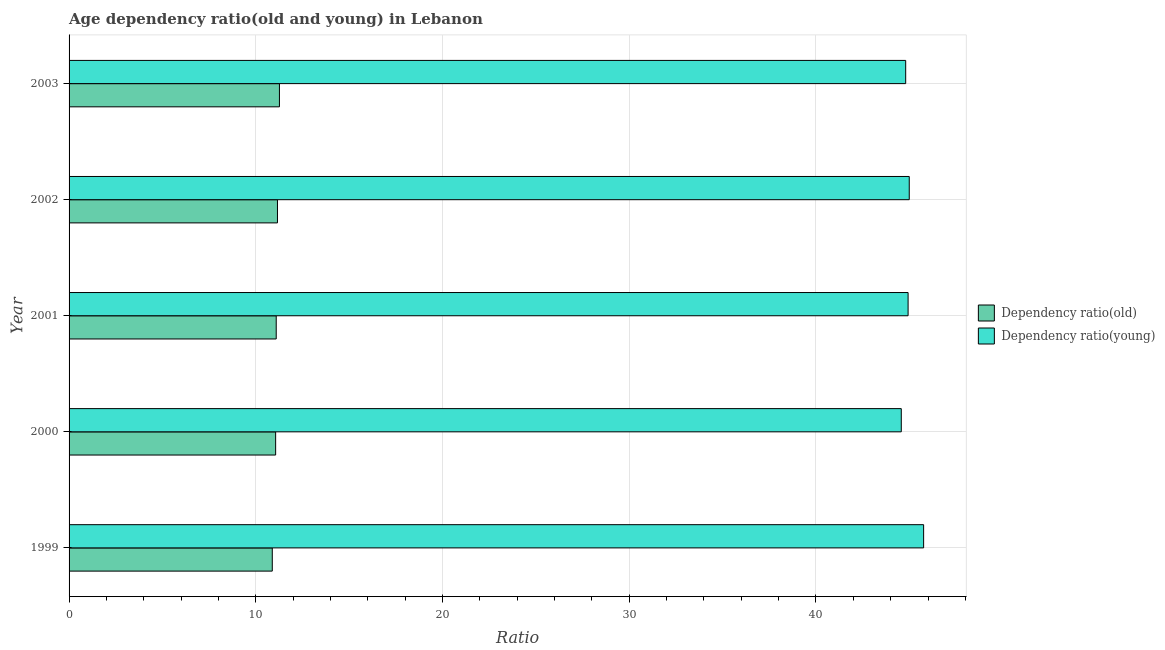How many groups of bars are there?
Give a very brief answer. 5. Are the number of bars on each tick of the Y-axis equal?
Keep it short and to the point. Yes. How many bars are there on the 3rd tick from the bottom?
Your answer should be very brief. 2. What is the age dependency ratio(old) in 2003?
Your response must be concise. 11.27. Across all years, what is the maximum age dependency ratio(young)?
Provide a short and direct response. 45.77. Across all years, what is the minimum age dependency ratio(old)?
Give a very brief answer. 10.88. In which year was the age dependency ratio(old) maximum?
Give a very brief answer. 2003. What is the total age dependency ratio(old) in the graph?
Your answer should be compact. 55.47. What is the difference between the age dependency ratio(old) in 2001 and that in 2003?
Your answer should be compact. -0.17. What is the difference between the age dependency ratio(young) in 1999 and the age dependency ratio(old) in 2000?
Keep it short and to the point. 34.7. What is the average age dependency ratio(young) per year?
Keep it short and to the point. 45.01. In the year 2000, what is the difference between the age dependency ratio(old) and age dependency ratio(young)?
Keep it short and to the point. -33.51. What is the ratio of the age dependency ratio(young) in 2002 to that in 2003?
Give a very brief answer. 1. Is the difference between the age dependency ratio(young) in 1999 and 2000 greater than the difference between the age dependency ratio(old) in 1999 and 2000?
Ensure brevity in your answer.  Yes. What is the difference between the highest and the second highest age dependency ratio(young)?
Make the answer very short. 0.77. What is the difference between the highest and the lowest age dependency ratio(old)?
Your response must be concise. 0.38. What does the 2nd bar from the top in 1999 represents?
Your answer should be very brief. Dependency ratio(old). What does the 2nd bar from the bottom in 1999 represents?
Offer a terse response. Dependency ratio(young). How many bars are there?
Provide a short and direct response. 10. Does the graph contain any zero values?
Provide a succinct answer. No. Where does the legend appear in the graph?
Provide a short and direct response. Center right. How are the legend labels stacked?
Your answer should be compact. Vertical. What is the title of the graph?
Make the answer very short. Age dependency ratio(old and young) in Lebanon. Does "Malaria" appear as one of the legend labels in the graph?
Your answer should be very brief. No. What is the label or title of the X-axis?
Your answer should be compact. Ratio. What is the label or title of the Y-axis?
Provide a succinct answer. Year. What is the Ratio of Dependency ratio(old) in 1999?
Your response must be concise. 10.88. What is the Ratio of Dependency ratio(young) in 1999?
Ensure brevity in your answer.  45.77. What is the Ratio in Dependency ratio(old) in 2000?
Offer a very short reply. 11.06. What is the Ratio in Dependency ratio(young) in 2000?
Your answer should be very brief. 44.57. What is the Ratio of Dependency ratio(old) in 2001?
Your answer should be compact. 11.09. What is the Ratio in Dependency ratio(young) in 2001?
Offer a terse response. 44.93. What is the Ratio in Dependency ratio(old) in 2002?
Make the answer very short. 11.16. What is the Ratio of Dependency ratio(young) in 2002?
Your answer should be compact. 45. What is the Ratio of Dependency ratio(old) in 2003?
Give a very brief answer. 11.27. What is the Ratio of Dependency ratio(young) in 2003?
Your response must be concise. 44.81. Across all years, what is the maximum Ratio in Dependency ratio(old)?
Your response must be concise. 11.27. Across all years, what is the maximum Ratio in Dependency ratio(young)?
Keep it short and to the point. 45.77. Across all years, what is the minimum Ratio of Dependency ratio(old)?
Offer a terse response. 10.88. Across all years, what is the minimum Ratio of Dependency ratio(young)?
Ensure brevity in your answer.  44.57. What is the total Ratio of Dependency ratio(old) in the graph?
Your response must be concise. 55.47. What is the total Ratio of Dependency ratio(young) in the graph?
Make the answer very short. 225.07. What is the difference between the Ratio of Dependency ratio(old) in 1999 and that in 2000?
Offer a terse response. -0.18. What is the difference between the Ratio in Dependency ratio(young) in 1999 and that in 2000?
Provide a succinct answer. 1.2. What is the difference between the Ratio in Dependency ratio(old) in 1999 and that in 2001?
Provide a succinct answer. -0.21. What is the difference between the Ratio of Dependency ratio(young) in 1999 and that in 2001?
Give a very brief answer. 0.83. What is the difference between the Ratio of Dependency ratio(old) in 1999 and that in 2002?
Keep it short and to the point. -0.28. What is the difference between the Ratio in Dependency ratio(young) in 1999 and that in 2002?
Make the answer very short. 0.77. What is the difference between the Ratio of Dependency ratio(old) in 1999 and that in 2003?
Your response must be concise. -0.38. What is the difference between the Ratio of Dependency ratio(young) in 1999 and that in 2003?
Keep it short and to the point. 0.96. What is the difference between the Ratio of Dependency ratio(old) in 2000 and that in 2001?
Make the answer very short. -0.03. What is the difference between the Ratio in Dependency ratio(young) in 2000 and that in 2001?
Make the answer very short. -0.36. What is the difference between the Ratio of Dependency ratio(old) in 2000 and that in 2002?
Make the answer very short. -0.1. What is the difference between the Ratio of Dependency ratio(young) in 2000 and that in 2002?
Your response must be concise. -0.43. What is the difference between the Ratio of Dependency ratio(old) in 2000 and that in 2003?
Offer a very short reply. -0.2. What is the difference between the Ratio of Dependency ratio(young) in 2000 and that in 2003?
Ensure brevity in your answer.  -0.24. What is the difference between the Ratio of Dependency ratio(old) in 2001 and that in 2002?
Your response must be concise. -0.07. What is the difference between the Ratio of Dependency ratio(young) in 2001 and that in 2002?
Give a very brief answer. -0.06. What is the difference between the Ratio of Dependency ratio(old) in 2001 and that in 2003?
Your response must be concise. -0.17. What is the difference between the Ratio in Dependency ratio(young) in 2001 and that in 2003?
Make the answer very short. 0.13. What is the difference between the Ratio of Dependency ratio(old) in 2002 and that in 2003?
Your response must be concise. -0.11. What is the difference between the Ratio of Dependency ratio(young) in 2002 and that in 2003?
Offer a very short reply. 0.19. What is the difference between the Ratio of Dependency ratio(old) in 1999 and the Ratio of Dependency ratio(young) in 2000?
Offer a very short reply. -33.69. What is the difference between the Ratio in Dependency ratio(old) in 1999 and the Ratio in Dependency ratio(young) in 2001?
Offer a very short reply. -34.05. What is the difference between the Ratio of Dependency ratio(old) in 1999 and the Ratio of Dependency ratio(young) in 2002?
Ensure brevity in your answer.  -34.11. What is the difference between the Ratio in Dependency ratio(old) in 1999 and the Ratio in Dependency ratio(young) in 2003?
Your response must be concise. -33.92. What is the difference between the Ratio of Dependency ratio(old) in 2000 and the Ratio of Dependency ratio(young) in 2001?
Your response must be concise. -33.87. What is the difference between the Ratio of Dependency ratio(old) in 2000 and the Ratio of Dependency ratio(young) in 2002?
Offer a very short reply. -33.93. What is the difference between the Ratio of Dependency ratio(old) in 2000 and the Ratio of Dependency ratio(young) in 2003?
Provide a short and direct response. -33.74. What is the difference between the Ratio in Dependency ratio(old) in 2001 and the Ratio in Dependency ratio(young) in 2002?
Provide a succinct answer. -33.9. What is the difference between the Ratio in Dependency ratio(old) in 2001 and the Ratio in Dependency ratio(young) in 2003?
Offer a terse response. -33.71. What is the difference between the Ratio in Dependency ratio(old) in 2002 and the Ratio in Dependency ratio(young) in 2003?
Your answer should be very brief. -33.64. What is the average Ratio in Dependency ratio(old) per year?
Make the answer very short. 11.09. What is the average Ratio of Dependency ratio(young) per year?
Your answer should be very brief. 45.01. In the year 1999, what is the difference between the Ratio in Dependency ratio(old) and Ratio in Dependency ratio(young)?
Offer a terse response. -34.88. In the year 2000, what is the difference between the Ratio of Dependency ratio(old) and Ratio of Dependency ratio(young)?
Give a very brief answer. -33.51. In the year 2001, what is the difference between the Ratio in Dependency ratio(old) and Ratio in Dependency ratio(young)?
Provide a succinct answer. -33.84. In the year 2002, what is the difference between the Ratio in Dependency ratio(old) and Ratio in Dependency ratio(young)?
Ensure brevity in your answer.  -33.83. In the year 2003, what is the difference between the Ratio of Dependency ratio(old) and Ratio of Dependency ratio(young)?
Your answer should be very brief. -33.54. What is the ratio of the Ratio in Dependency ratio(old) in 1999 to that in 2000?
Your answer should be very brief. 0.98. What is the ratio of the Ratio in Dependency ratio(young) in 1999 to that in 2000?
Offer a terse response. 1.03. What is the ratio of the Ratio in Dependency ratio(young) in 1999 to that in 2001?
Make the answer very short. 1.02. What is the ratio of the Ratio of Dependency ratio(old) in 1999 to that in 2002?
Provide a short and direct response. 0.98. What is the ratio of the Ratio in Dependency ratio(young) in 1999 to that in 2002?
Your answer should be compact. 1.02. What is the ratio of the Ratio of Dependency ratio(old) in 1999 to that in 2003?
Give a very brief answer. 0.97. What is the ratio of the Ratio of Dependency ratio(young) in 1999 to that in 2003?
Your answer should be very brief. 1.02. What is the ratio of the Ratio in Dependency ratio(young) in 2000 to that in 2001?
Ensure brevity in your answer.  0.99. What is the ratio of the Ratio in Dependency ratio(old) in 2000 to that in 2002?
Ensure brevity in your answer.  0.99. What is the ratio of the Ratio in Dependency ratio(young) in 2000 to that in 2002?
Your answer should be compact. 0.99. What is the ratio of the Ratio in Dependency ratio(old) in 2000 to that in 2003?
Provide a succinct answer. 0.98. What is the ratio of the Ratio in Dependency ratio(young) in 2001 to that in 2002?
Your response must be concise. 1. What is the ratio of the Ratio in Dependency ratio(old) in 2001 to that in 2003?
Provide a succinct answer. 0.98. What is the ratio of the Ratio in Dependency ratio(young) in 2002 to that in 2003?
Your answer should be compact. 1. What is the difference between the highest and the second highest Ratio in Dependency ratio(old)?
Your answer should be very brief. 0.11. What is the difference between the highest and the second highest Ratio in Dependency ratio(young)?
Ensure brevity in your answer.  0.77. What is the difference between the highest and the lowest Ratio of Dependency ratio(old)?
Keep it short and to the point. 0.38. What is the difference between the highest and the lowest Ratio in Dependency ratio(young)?
Give a very brief answer. 1.2. 